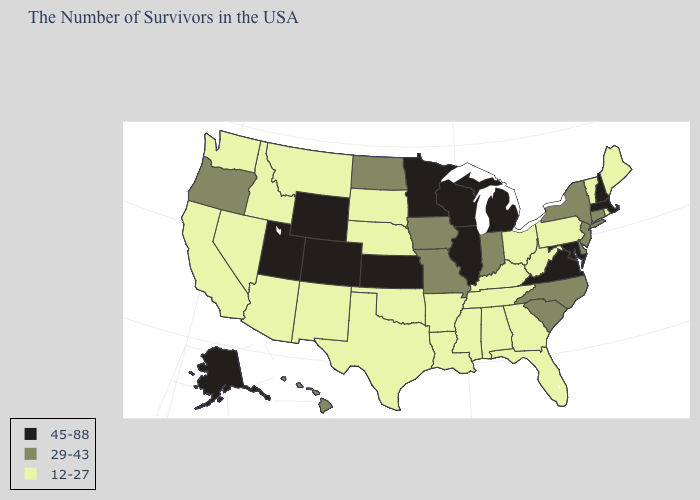What is the lowest value in states that border Arizona?
Keep it brief. 12-27. What is the value of Tennessee?
Short answer required. 12-27. What is the value of Connecticut?
Give a very brief answer. 29-43. Name the states that have a value in the range 12-27?
Answer briefly. Maine, Rhode Island, Vermont, Pennsylvania, West Virginia, Ohio, Florida, Georgia, Kentucky, Alabama, Tennessee, Mississippi, Louisiana, Arkansas, Nebraska, Oklahoma, Texas, South Dakota, New Mexico, Montana, Arizona, Idaho, Nevada, California, Washington. Does Tennessee have the lowest value in the South?
Be succinct. Yes. Does the first symbol in the legend represent the smallest category?
Concise answer only. No. What is the highest value in the USA?
Write a very short answer. 45-88. Does the first symbol in the legend represent the smallest category?
Quick response, please. No. Is the legend a continuous bar?
Be succinct. No. What is the value of Idaho?
Be succinct. 12-27. Does the map have missing data?
Short answer required. No. What is the lowest value in the USA?
Be succinct. 12-27. Does the first symbol in the legend represent the smallest category?
Be succinct. No. Among the states that border Pennsylvania , does Maryland have the highest value?
Keep it brief. Yes. 